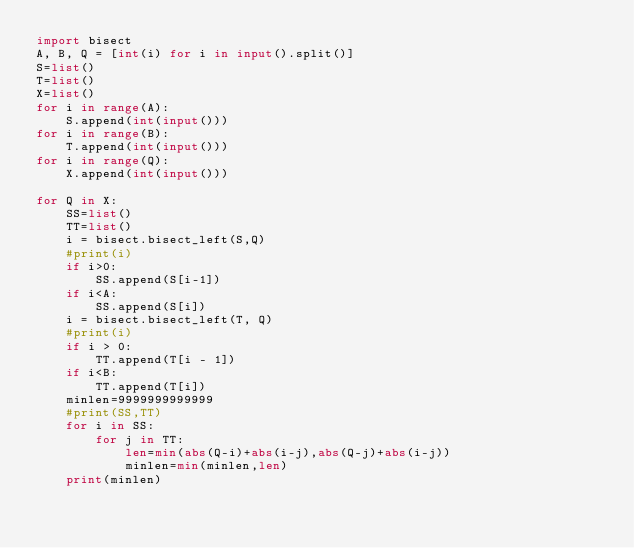<code> <loc_0><loc_0><loc_500><loc_500><_Python_>import bisect
A, B, Q = [int(i) for i in input().split()]
S=list()
T=list()
X=list()
for i in range(A):
    S.append(int(input()))
for i in range(B):
    T.append(int(input()))
for i in range(Q):
    X.append(int(input()))

for Q in X:
    SS=list()
    TT=list()
    i = bisect.bisect_left(S,Q)
    #print(i)
    if i>0:
        SS.append(S[i-1])
    if i<A:
        SS.append(S[i])
    i = bisect.bisect_left(T, Q)
    #print(i)
    if i > 0:
        TT.append(T[i - 1])
    if i<B:
        TT.append(T[i])
    minlen=9999999999999
    #print(SS,TT)
    for i in SS:
        for j in TT:
            len=min(abs(Q-i)+abs(i-j),abs(Q-j)+abs(i-j))
            minlen=min(minlen,len)
    print(minlen)

</code> 